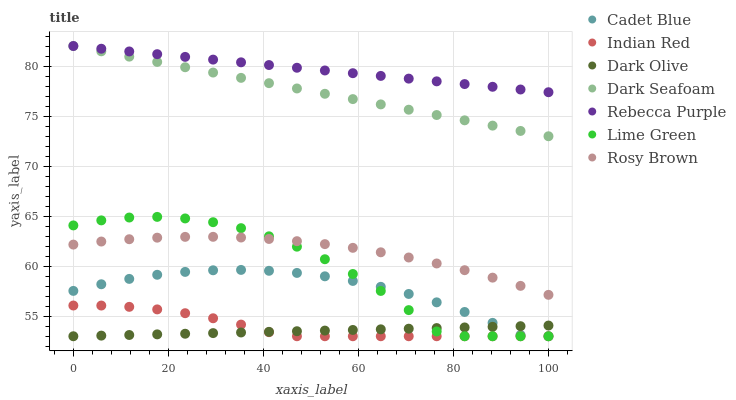Does Dark Olive have the minimum area under the curve?
Answer yes or no. Yes. Does Rebecca Purple have the maximum area under the curve?
Answer yes or no. Yes. Does Dark Seafoam have the minimum area under the curve?
Answer yes or no. No. Does Dark Seafoam have the maximum area under the curve?
Answer yes or no. No. Is Dark Olive the smoothest?
Answer yes or no. Yes. Is Lime Green the roughest?
Answer yes or no. Yes. Is Dark Seafoam the smoothest?
Answer yes or no. No. Is Dark Seafoam the roughest?
Answer yes or no. No. Does Cadet Blue have the lowest value?
Answer yes or no. Yes. Does Dark Seafoam have the lowest value?
Answer yes or no. No. Does Rebecca Purple have the highest value?
Answer yes or no. Yes. Does Dark Olive have the highest value?
Answer yes or no. No. Is Dark Olive less than Rebecca Purple?
Answer yes or no. Yes. Is Rosy Brown greater than Cadet Blue?
Answer yes or no. Yes. Does Lime Green intersect Rosy Brown?
Answer yes or no. Yes. Is Lime Green less than Rosy Brown?
Answer yes or no. No. Is Lime Green greater than Rosy Brown?
Answer yes or no. No. Does Dark Olive intersect Rebecca Purple?
Answer yes or no. No. 